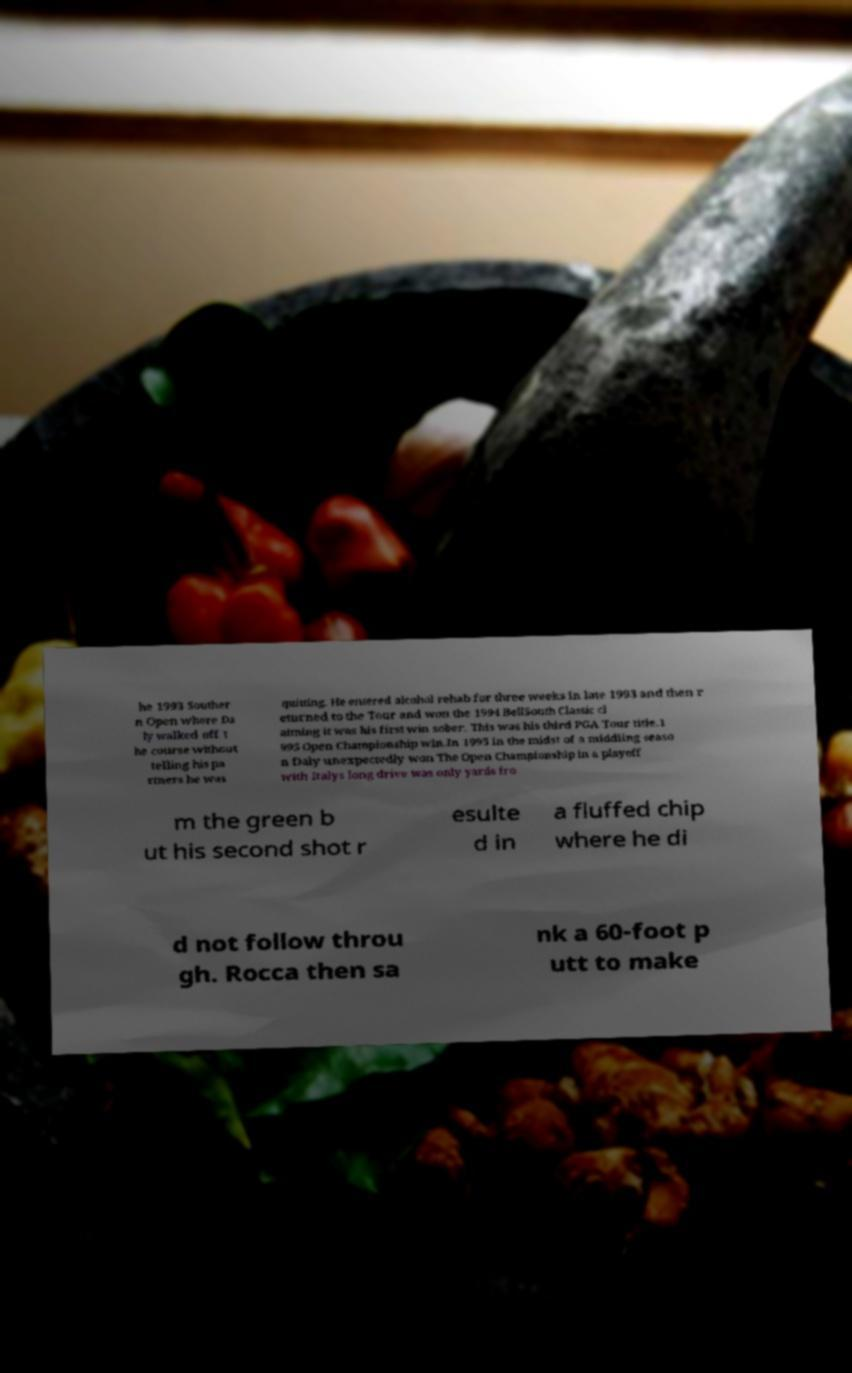Could you extract and type out the text from this image? he 1993 Souther n Open where Da ly walked off t he course without telling his pa rtners he was quitting. He entered alcohol rehab for three weeks in late 1993 and then r eturned to the Tour and won the 1994 BellSouth Classic cl aiming it was his first win sober. This was his third PGA Tour title.1 995 Open Championship win.In 1995 in the midst of a middling seaso n Daly unexpectedly won The Open Championship in a playoff with Italys long drive was only yards fro m the green b ut his second shot r esulte d in a fluffed chip where he di d not follow throu gh. Rocca then sa nk a 60-foot p utt to make 